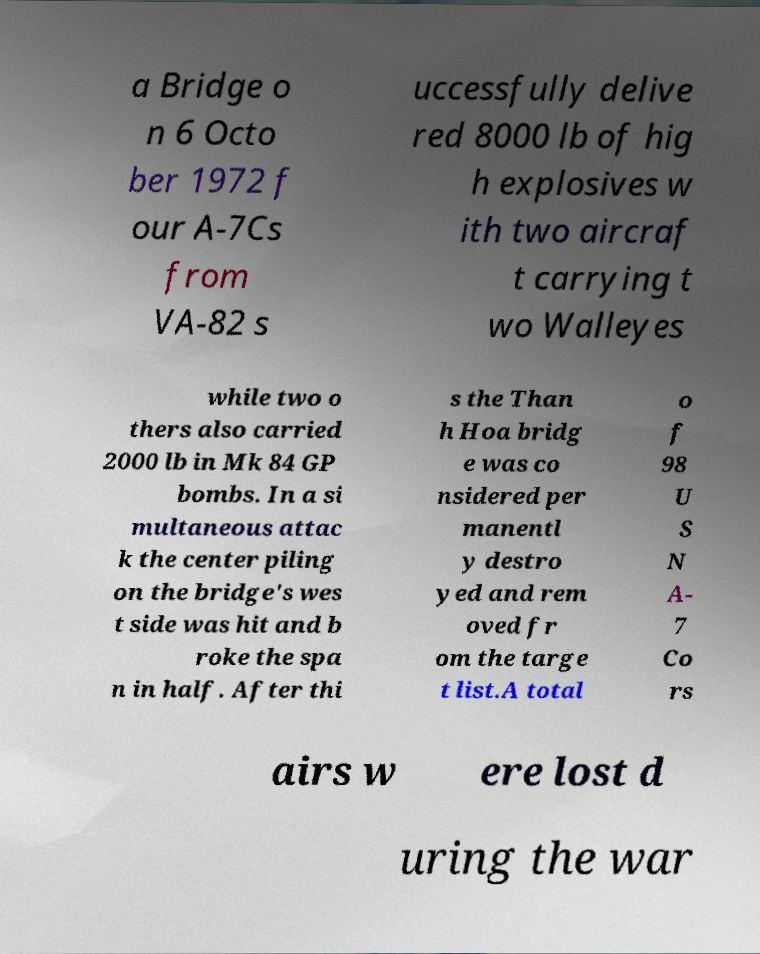Can you read and provide the text displayed in the image?This photo seems to have some interesting text. Can you extract and type it out for me? a Bridge o n 6 Octo ber 1972 f our A-7Cs from VA-82 s uccessfully delive red 8000 lb of hig h explosives w ith two aircraf t carrying t wo Walleyes while two o thers also carried 2000 lb in Mk 84 GP bombs. In a si multaneous attac k the center piling on the bridge's wes t side was hit and b roke the spa n in half. After thi s the Than h Hoa bridg e was co nsidered per manentl y destro yed and rem oved fr om the targe t list.A total o f 98 U S N A- 7 Co rs airs w ere lost d uring the war 